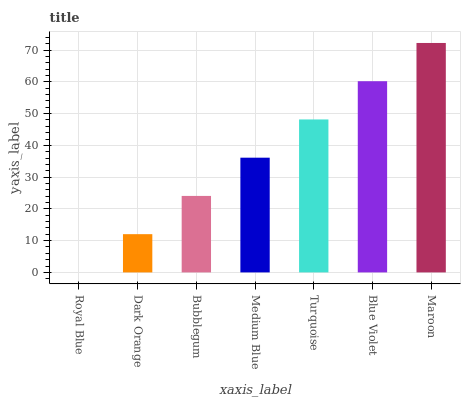Is Royal Blue the minimum?
Answer yes or no. Yes. Is Maroon the maximum?
Answer yes or no. Yes. Is Dark Orange the minimum?
Answer yes or no. No. Is Dark Orange the maximum?
Answer yes or no. No. Is Dark Orange greater than Royal Blue?
Answer yes or no. Yes. Is Royal Blue less than Dark Orange?
Answer yes or no. Yes. Is Royal Blue greater than Dark Orange?
Answer yes or no. No. Is Dark Orange less than Royal Blue?
Answer yes or no. No. Is Medium Blue the high median?
Answer yes or no. Yes. Is Medium Blue the low median?
Answer yes or no. Yes. Is Blue Violet the high median?
Answer yes or no. No. Is Royal Blue the low median?
Answer yes or no. No. 